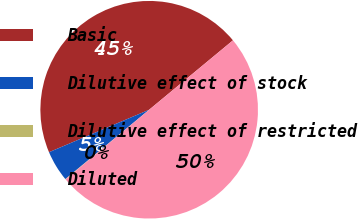Convert chart to OTSL. <chart><loc_0><loc_0><loc_500><loc_500><pie_chart><fcel>Basic<fcel>Dilutive effect of stock<fcel>Dilutive effect of restricted<fcel>Diluted<nl><fcel>45.38%<fcel>4.62%<fcel>0.05%<fcel>49.95%<nl></chart> 